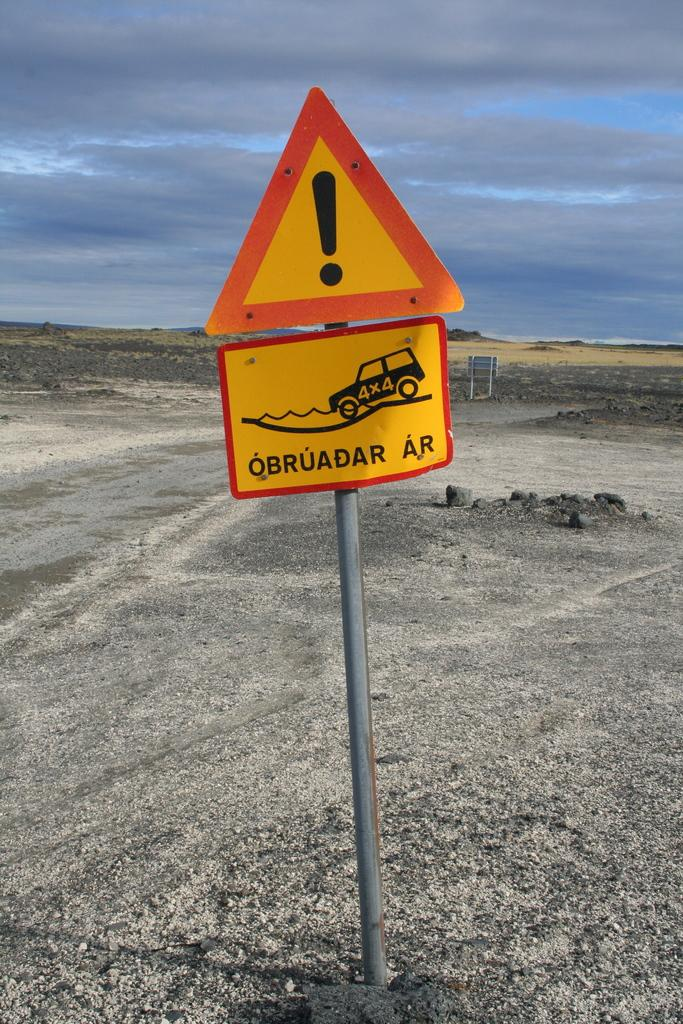<image>
Present a compact description of the photo's key features. A caution sign with the text OBRUADAR AR. 